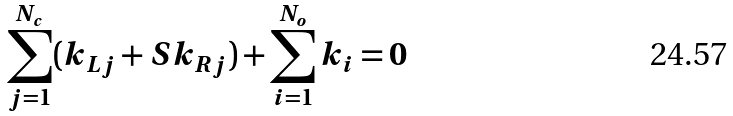<formula> <loc_0><loc_0><loc_500><loc_500>\sum _ { j = 1 } ^ { N _ { c } } ( k _ { L j } + S k _ { R j } ) + \sum _ { i = 1 } ^ { N _ { o } } k _ { i } = 0</formula> 